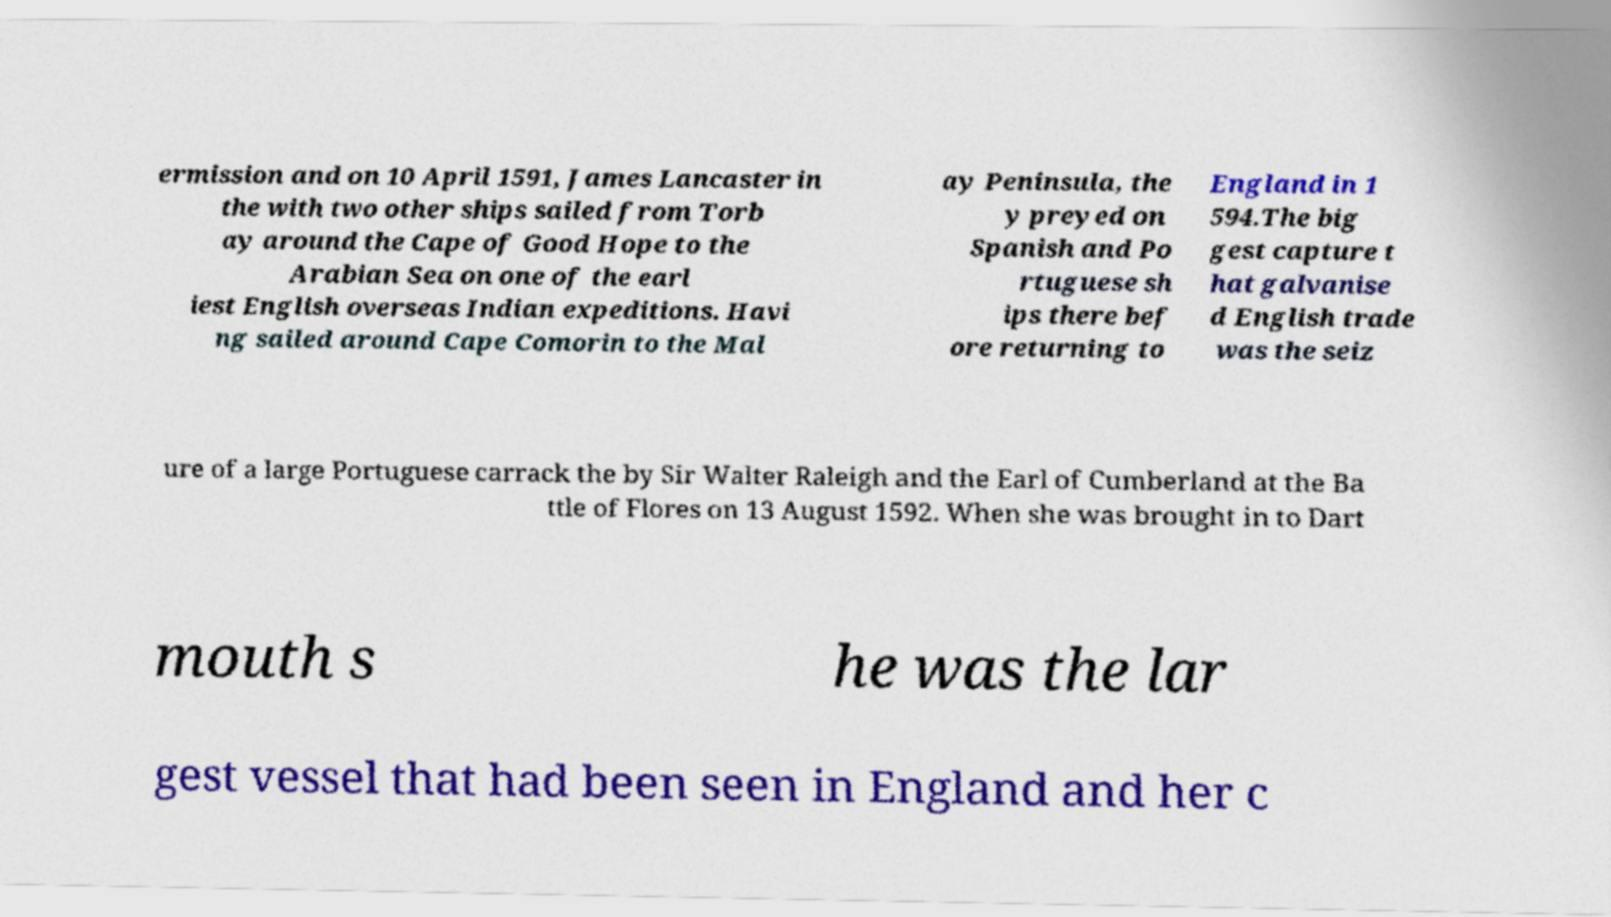I need the written content from this picture converted into text. Can you do that? ermission and on 10 April 1591, James Lancaster in the with two other ships sailed from Torb ay around the Cape of Good Hope to the Arabian Sea on one of the earl iest English overseas Indian expeditions. Havi ng sailed around Cape Comorin to the Mal ay Peninsula, the y preyed on Spanish and Po rtuguese sh ips there bef ore returning to England in 1 594.The big gest capture t hat galvanise d English trade was the seiz ure of a large Portuguese carrack the by Sir Walter Raleigh and the Earl of Cumberland at the Ba ttle of Flores on 13 August 1592. When she was brought in to Dart mouth s he was the lar gest vessel that had been seen in England and her c 